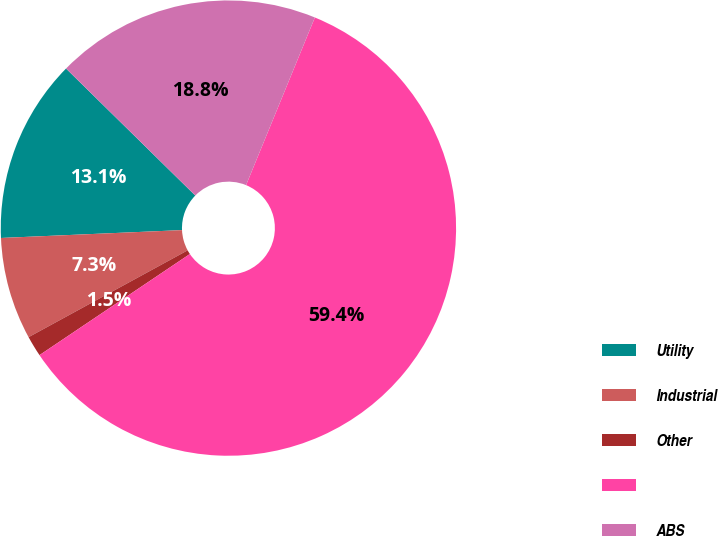Convert chart. <chart><loc_0><loc_0><loc_500><loc_500><pie_chart><fcel>Utility<fcel>Industrial<fcel>Other<fcel>Unnamed: 3<fcel>ABS<nl><fcel>13.05%<fcel>7.26%<fcel>1.47%<fcel>59.38%<fcel>18.84%<nl></chart> 